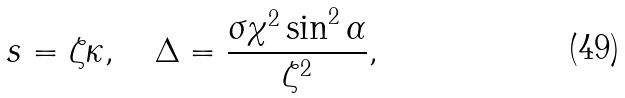<formula> <loc_0><loc_0><loc_500><loc_500>s = \zeta \kappa , \quad \Delta = \frac { \sigma \chi ^ { 2 } \sin ^ { 2 } \alpha } { \zeta ^ { 2 } } ,</formula> 